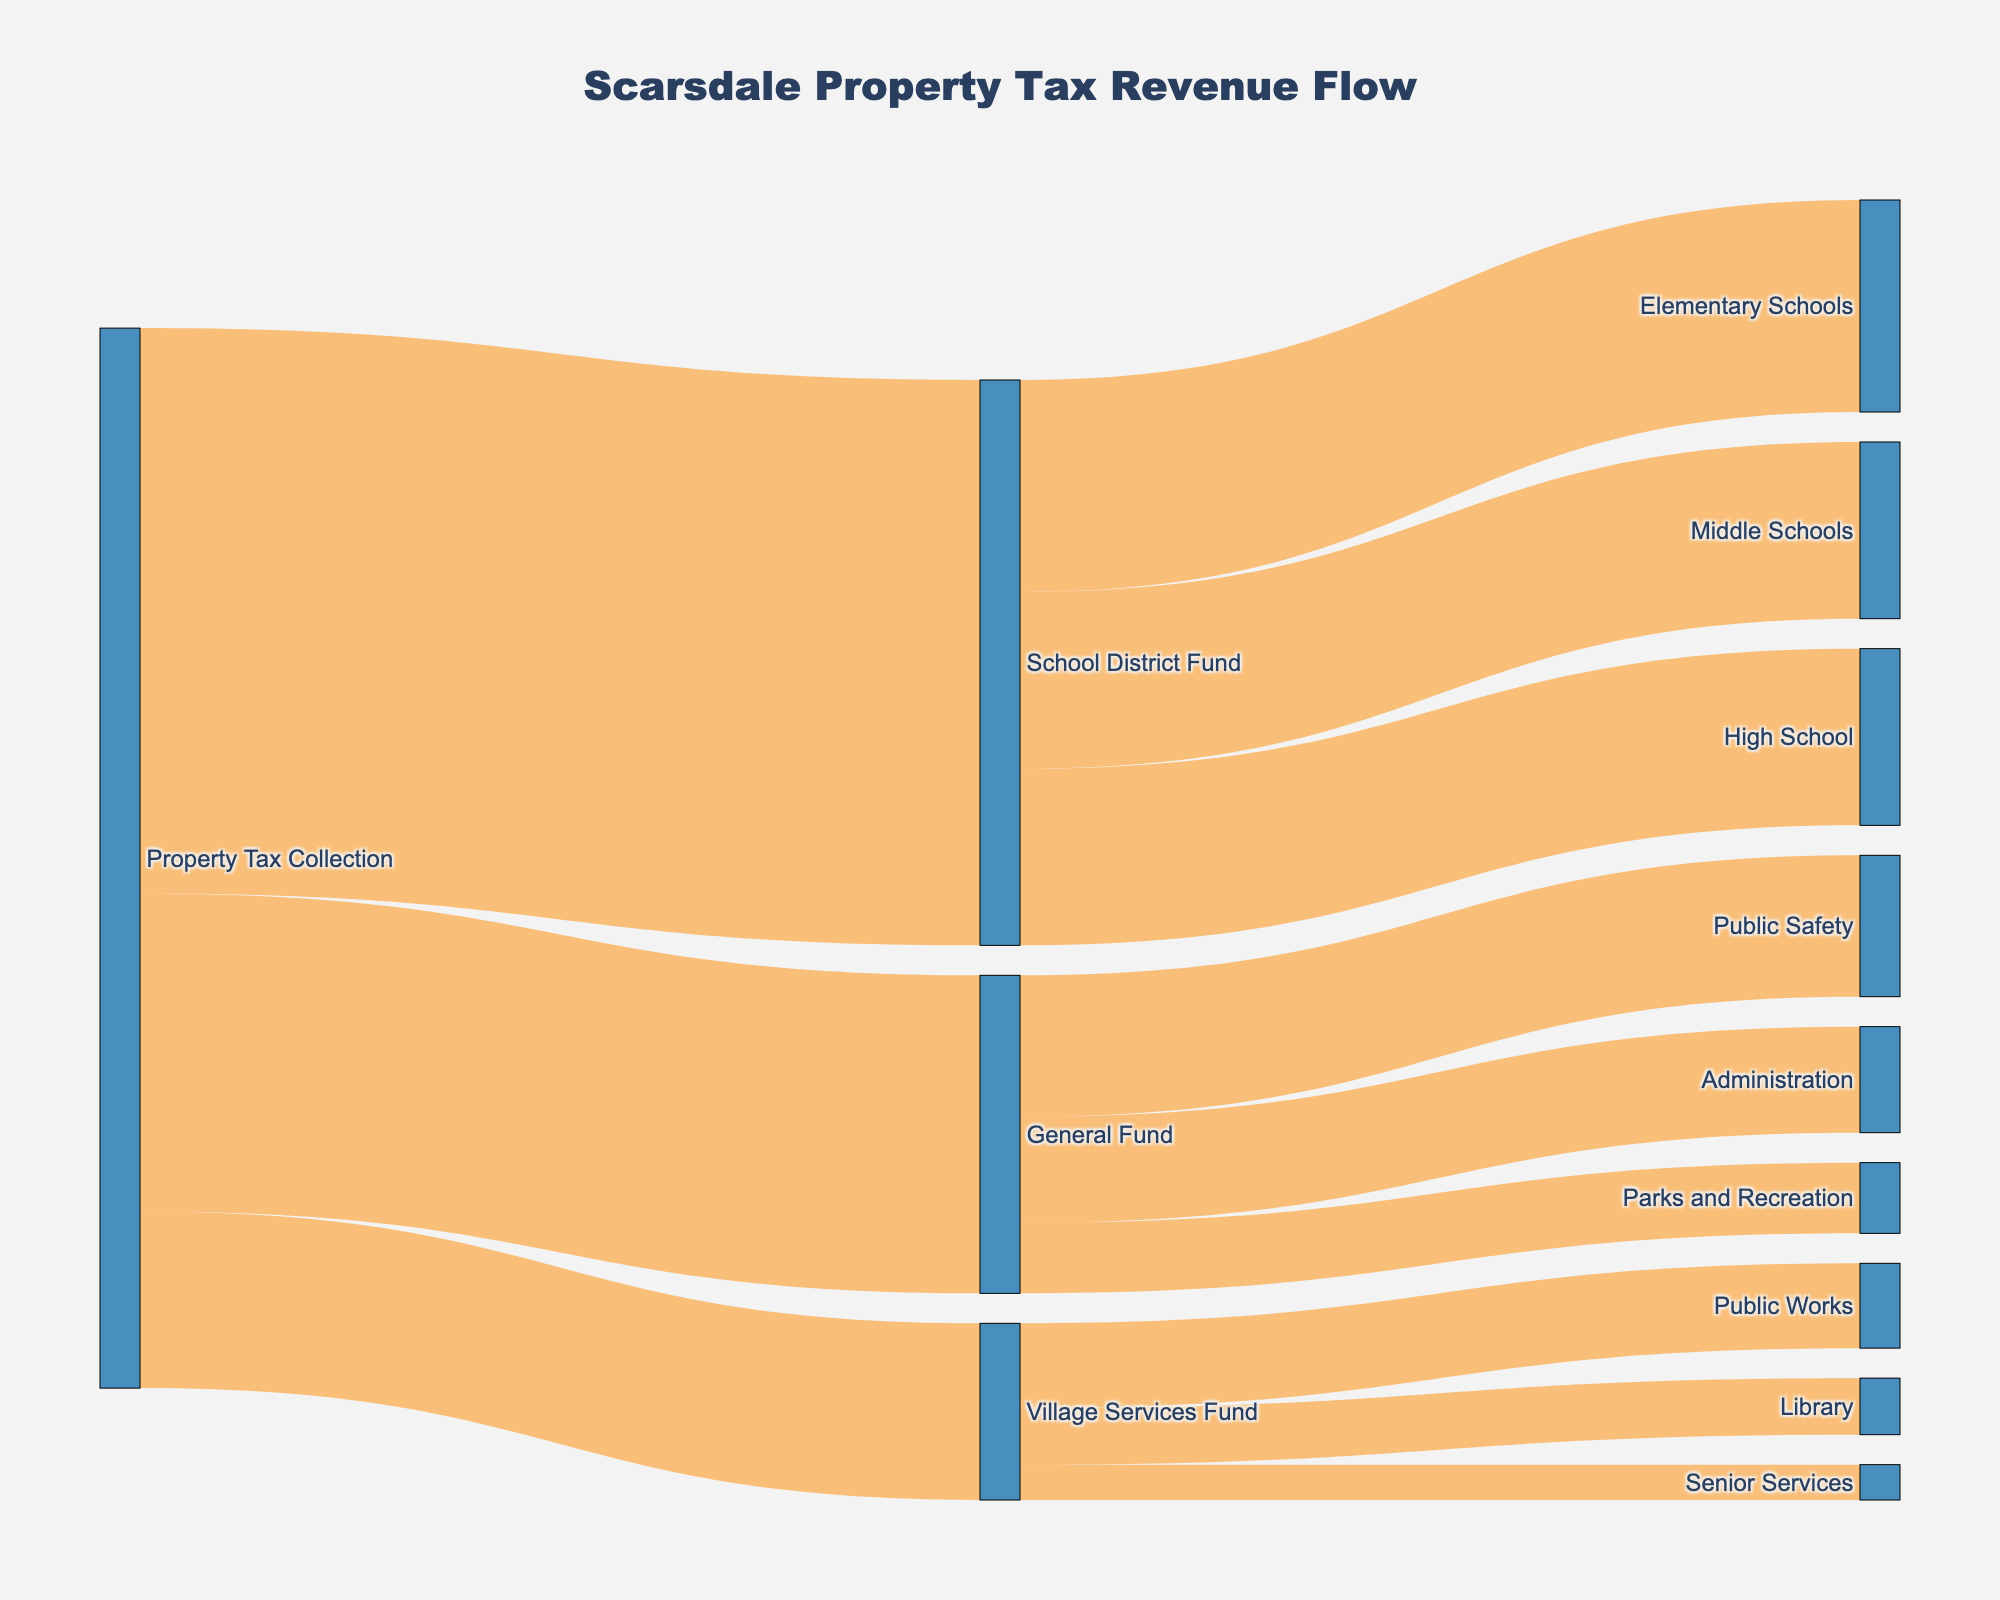what is the title of the figure? The title is typically displayed at the top of the figure, summarizing what the figure represents.
Answer: Scarsdale Property Tax Revenue Flow which fund receives the largest allocation from Property Tax Collection? To find this, look at the flows originating from Property Tax Collection and identify the one with the highest value. The School District Fund receives $80,000,000, which is the highest.
Answer: School District Fund how much total funding does the General Fund allocate to all its targets? Sum up the values for Public Safety, Administration, and Parks and Recreation. These values are $20,000,000, $15,000,000, and $10,000,000 respectively. So, the total is $20,000,000 + $15,000,000 + $10,000,000 = $45,000,000.
Answer: $45,000,000 which service receives the least funding from the Village Services Fund? Compare the allocations from the Village Services Fund. Senior Services receive $5,000,000, which is the smallest allocation.
Answer: Senior Services is the funding for High School and Middle Schools equal? Compare the values for High School ($25,000,000) and Middle Schools ($25,000,000). Both receive the same amount of funding.
Answer: Yes what is the combined funding for Public Works and Library? Sum the allocations for Public Works ($12,000,000) and Library ($8,000,000). The total combined funding is $12,000,000 + $8,000,000 = $20,000,000.
Answer: $20,000,000 which service has the highest allocation from the General Fund? Compare the funding for Public Safety, Administration, and Parks and Recreation. Public Safety receives $20,000,000, which is the highest allocation.
Answer: Public Safety how does the total funding for Elementary Schools compare to the total funding for Parks and Recreation? Compare the values: Elementary Schools receive $30,000,000, and Parks and Recreation receive $10,000,000. Elementary Schools receive more funding by $20,000,000.
Answer: Elementary Schools receive $20,000,000 more does Public Safety receive more or less funding than Public Works, and by how much? Public Safety receives $20,000,000, while Public Works receives $12,000,000. To find the difference: $20,000,000 - $12,000,000 = $8,000,000. Public Safety receives $8,000,000 more.
Answer: Public Safety receives $8,000,000 more 